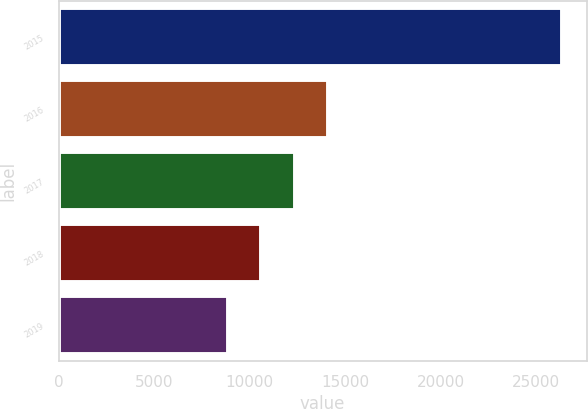<chart> <loc_0><loc_0><loc_500><loc_500><bar_chart><fcel>2015<fcel>2016<fcel>2017<fcel>2018<fcel>2019<nl><fcel>26329<fcel>14109.8<fcel>12364.2<fcel>10618.6<fcel>8873<nl></chart> 